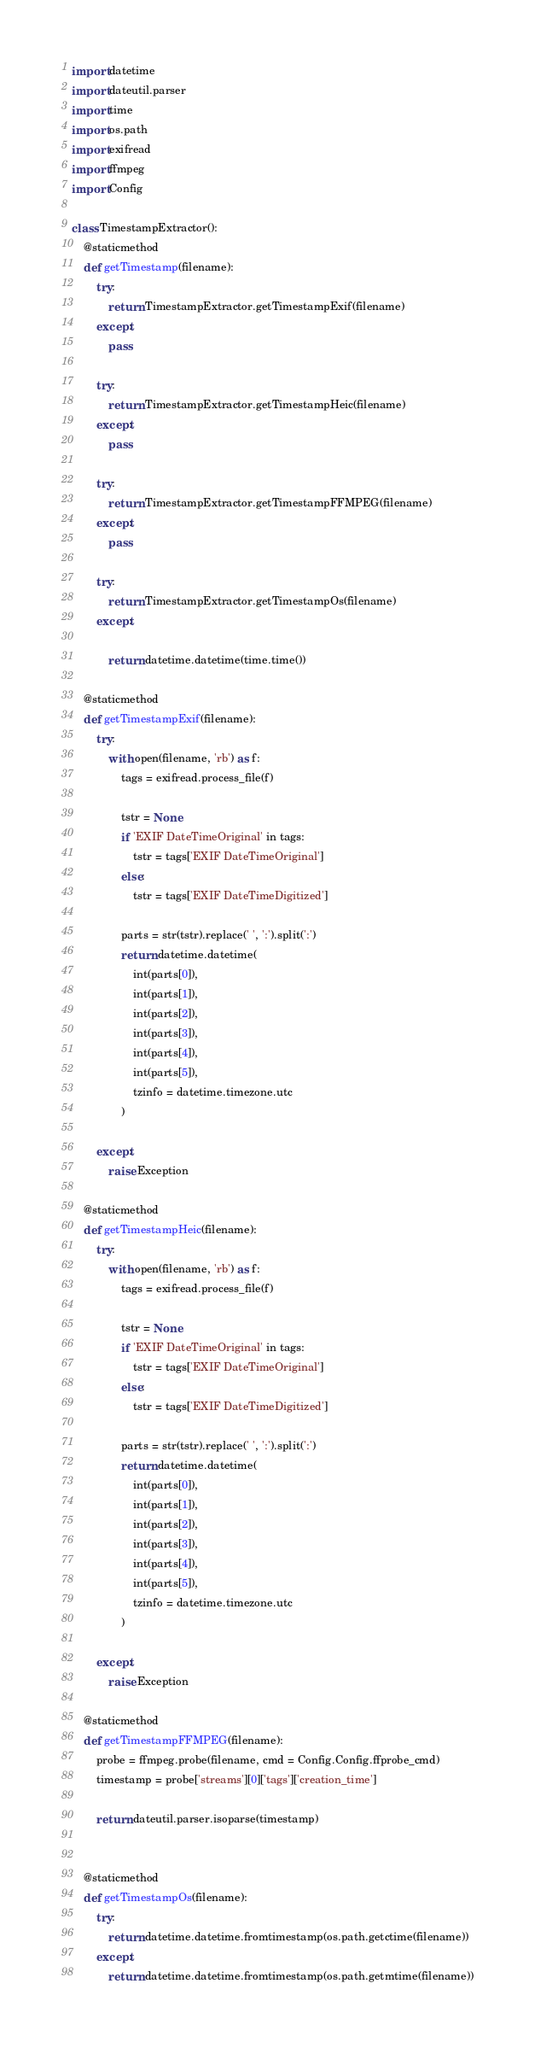Convert code to text. <code><loc_0><loc_0><loc_500><loc_500><_Python_>import datetime
import dateutil.parser
import time
import os.path
import exifread
import ffmpeg
import Config

class TimestampExtractor():
    @staticmethod
    def getTimestamp(filename):
        try:
            return TimestampExtractor.getTimestampExif(filename)
        except:
            pass

        try:
            return TimestampExtractor.getTimestampHeic(filename)
        except:
            pass

        try:
            return TimestampExtractor.getTimestampFFMPEG(filename)
        except:
            pass

        try:
            return TimestampExtractor.getTimestampOs(filename)
        except:
            
            return datetime.datetime(time.time())

    @staticmethod
    def getTimestampExif(filename):
        try:
            with open(filename, 'rb') as f:
                tags = exifread.process_file(f)

                tstr = None
                if 'EXIF DateTimeOriginal' in tags:
                    tstr = tags['EXIF DateTimeOriginal']
                else:
                    tstr = tags['EXIF DateTimeDigitized']

                parts = str(tstr).replace(' ', ':').split(':')
                return datetime.datetime(
                    int(parts[0]),
                    int(parts[1]),
                    int(parts[2]),
                    int(parts[3]),
                    int(parts[4]),
                    int(parts[5]),
                    tzinfo = datetime.timezone.utc
                )

        except:
            raise Exception

    @staticmethod
    def getTimestampHeic(filename):
        try:
            with open(filename, 'rb') as f:
                tags = exifread.process_file(f)

                tstr = None
                if 'EXIF DateTimeOriginal' in tags:
                    tstr = tags['EXIF DateTimeOriginal']
                else:
                    tstr = tags['EXIF DateTimeDigitized']

                parts = str(tstr).replace(' ', ':').split(':')
                return datetime.datetime(
                    int(parts[0]),
                    int(parts[1]),
                    int(parts[2]),
                    int(parts[3]),
                    int(parts[4]),
                    int(parts[5]),
                    tzinfo = datetime.timezone.utc
                )

        except:
            raise Exception

    @staticmethod
    def getTimestampFFMPEG(filename):
        probe = ffmpeg.probe(filename, cmd = Config.Config.ffprobe_cmd)
        timestamp = probe['streams'][0]['tags']['creation_time']

        return dateutil.parser.isoparse(timestamp)


    @staticmethod
    def getTimestampOs(filename):
        try:
            return datetime.datetime.fromtimestamp(os.path.getctime(filename))
        except:
            return datetime.datetime.fromtimestamp(os.path.getmtime(filename))</code> 